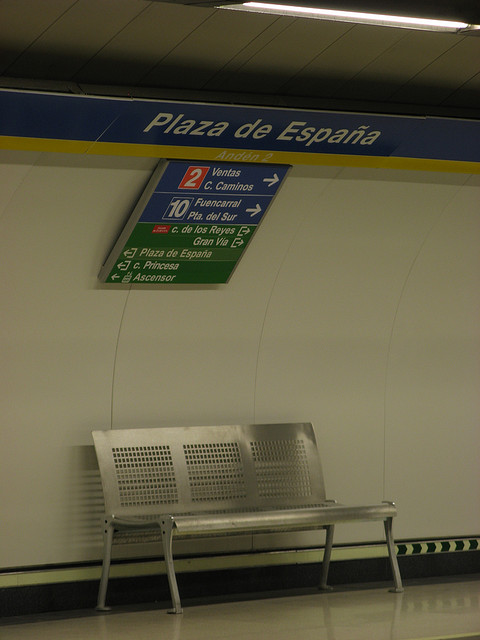What kind of information is displayed on the sign? The sign displays directional information, including line numbers and the names of destinations serviced by those lines, such as 'Ventas' and 'Fuencarral', along with symbols indicating the presence of an elevator.  Describe the bench design in the picture. The bench in the picture is made up of a series of perforated metal seats, mounted on what appears to be a single metal frame, creating a modern and functional seating area. 